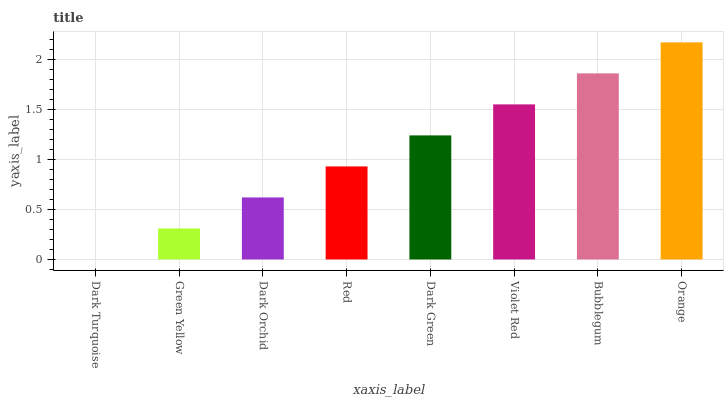Is Dark Turquoise the minimum?
Answer yes or no. Yes. Is Orange the maximum?
Answer yes or no. Yes. Is Green Yellow the minimum?
Answer yes or no. No. Is Green Yellow the maximum?
Answer yes or no. No. Is Green Yellow greater than Dark Turquoise?
Answer yes or no. Yes. Is Dark Turquoise less than Green Yellow?
Answer yes or no. Yes. Is Dark Turquoise greater than Green Yellow?
Answer yes or no. No. Is Green Yellow less than Dark Turquoise?
Answer yes or no. No. Is Dark Green the high median?
Answer yes or no. Yes. Is Red the low median?
Answer yes or no. Yes. Is Dark Orchid the high median?
Answer yes or no. No. Is Green Yellow the low median?
Answer yes or no. No. 